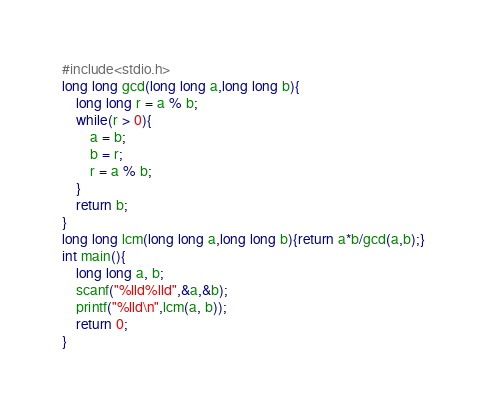<code> <loc_0><loc_0><loc_500><loc_500><_C_>#include<stdio.h>
long long gcd(long long a,long long b){
    long long r = a % b;
    while(r > 0){
        a = b;
        b = r;
        r = a % b;
    }
    return b;
}
long long lcm(long long a,long long b){return a*b/gcd(a,b);}
int main(){
    long long a, b;
    scanf("%lld%lld",&a,&b);
    printf("%lld\n",lcm(a, b));
    return 0;
}</code> 